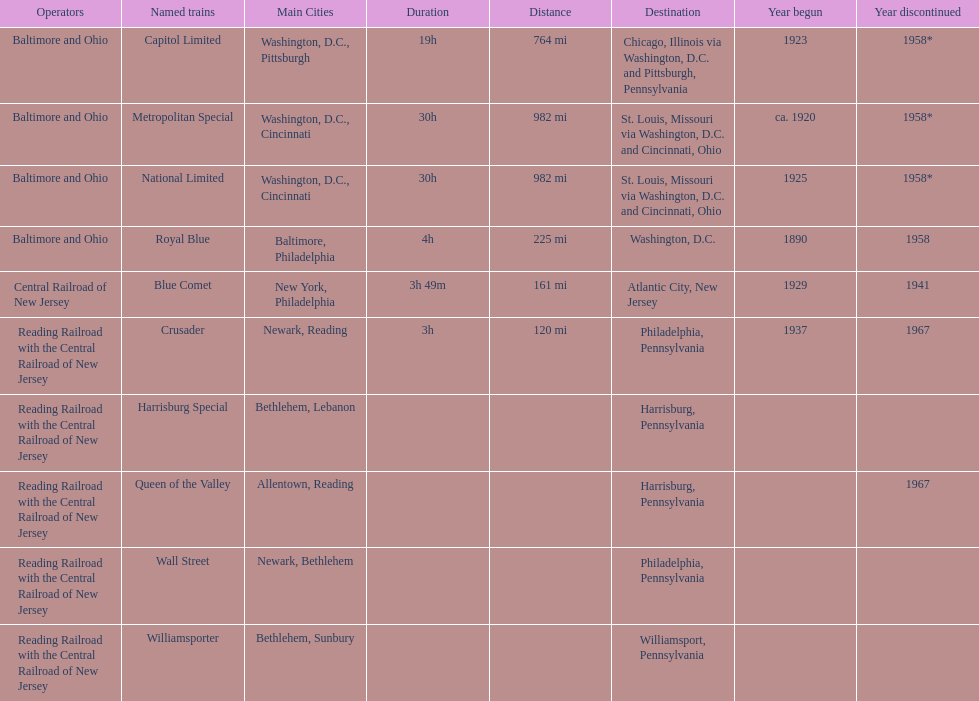Which of the trains are operated by reading railroad with the central railroad of new jersey? Crusader, Harrisburg Special, Queen of the Valley, Wall Street, Williamsporter. Of these trains, which of them had a destination of philadelphia, pennsylvania? Crusader, Wall Street. Out of these two trains, which one is discontinued? Crusader. 